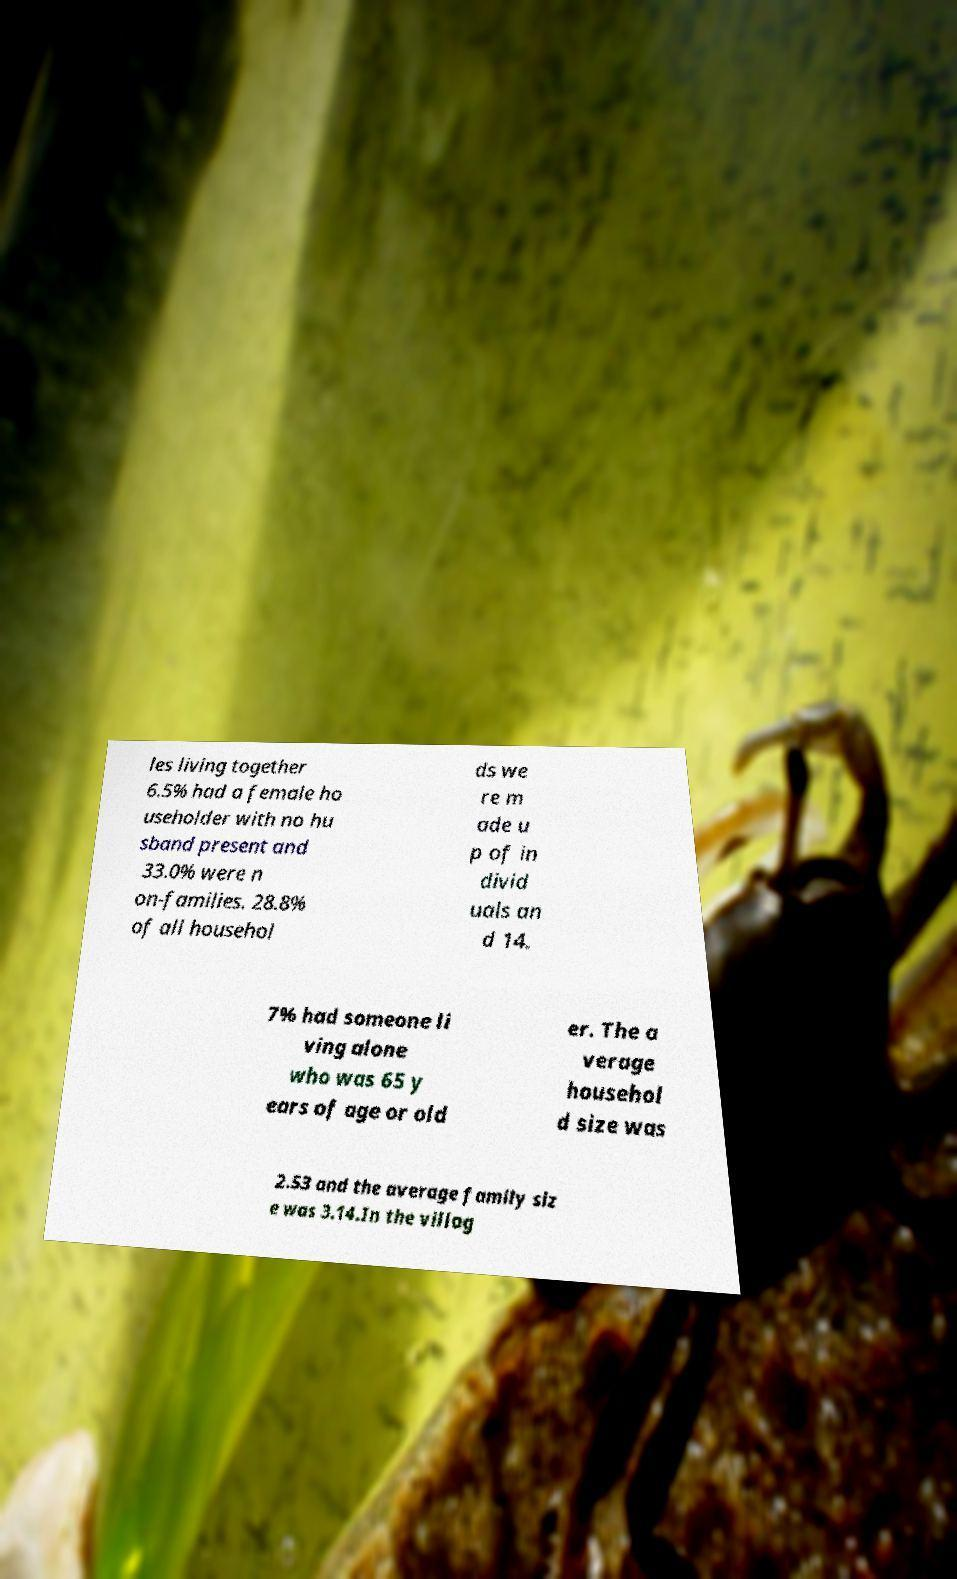What messages or text are displayed in this image? I need them in a readable, typed format. les living together 6.5% had a female ho useholder with no hu sband present and 33.0% were n on-families. 28.8% of all househol ds we re m ade u p of in divid uals an d 14. 7% had someone li ving alone who was 65 y ears of age or old er. The a verage househol d size was 2.53 and the average family siz e was 3.14.In the villag 